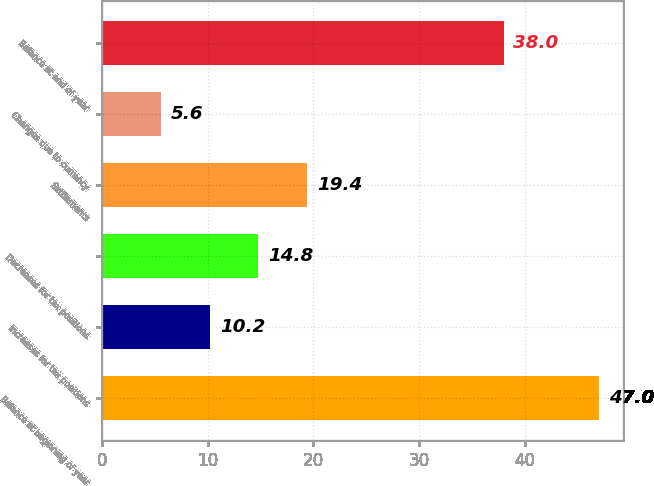Convert chart. <chart><loc_0><loc_0><loc_500><loc_500><bar_chart><fcel>Balance at beginning of year<fcel>Increases for tax positions<fcel>Decreases for tax positions<fcel>Settlements<fcel>Changes due to currency<fcel>Balance at end of year<nl><fcel>47<fcel>10.2<fcel>14.8<fcel>19.4<fcel>5.6<fcel>38<nl></chart> 